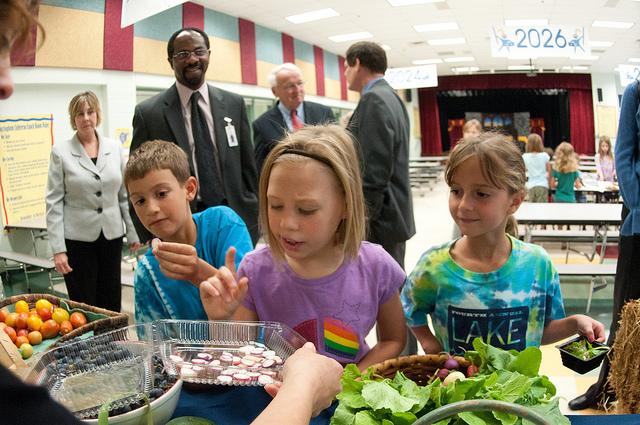Are the women shopping?
Keep it brief. No. What is next the Kale?
Write a very short answer. Radishes. Are the children getting junk food?
Answer briefly. No. What number is in the top right corner?
Quick response, please. 2026. What food is the girl in the purple shirt looking at?
Be succinct. Radish. How many blue shirts are in the photo?
Be succinct. 2. Is there a scarf in this picture?
Quick response, please. No. Are the people adults?
Concise answer only. No. 